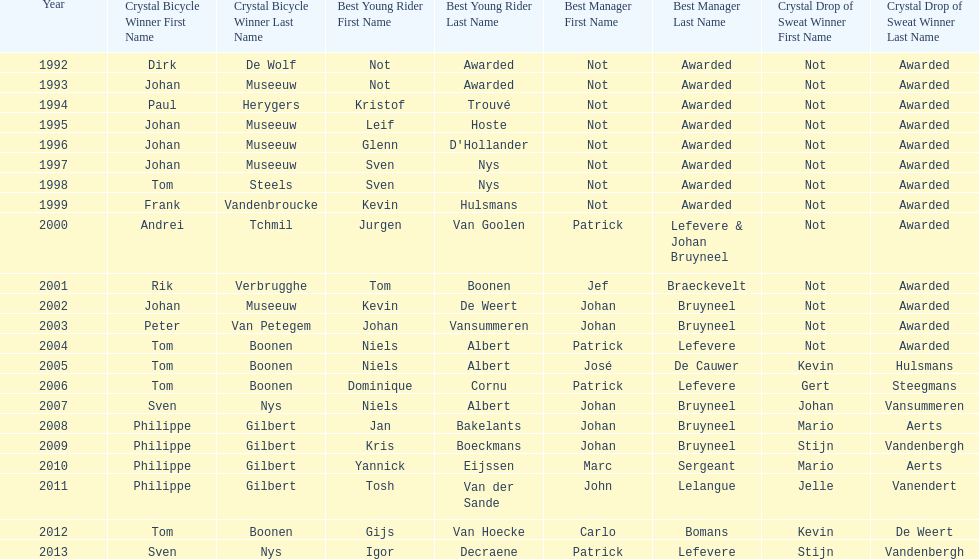What is the total number of times johan bryneel's name appears on all of these lists? 6. 